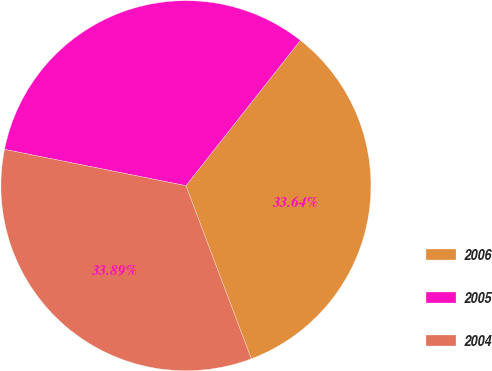<chart> <loc_0><loc_0><loc_500><loc_500><pie_chart><fcel>2006<fcel>2005<fcel>2004<nl><fcel>33.64%<fcel>32.47%<fcel>33.89%<nl></chart> 